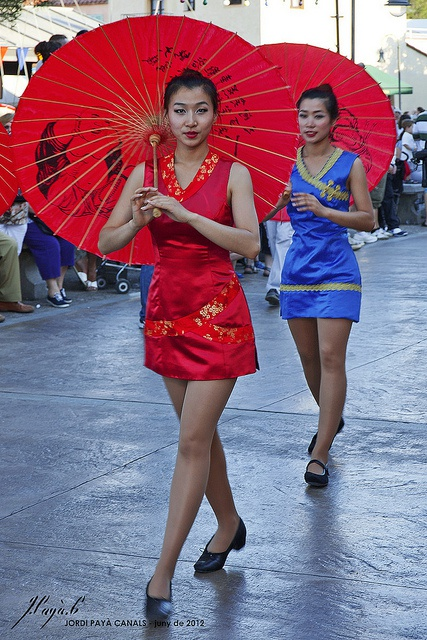Describe the objects in this image and their specific colors. I can see people in black, brown, maroon, and gray tones, umbrella in black, brown, and maroon tones, people in black, gray, blue, and darkblue tones, umbrella in black and brown tones, and people in black, navy, gray, and darkblue tones in this image. 